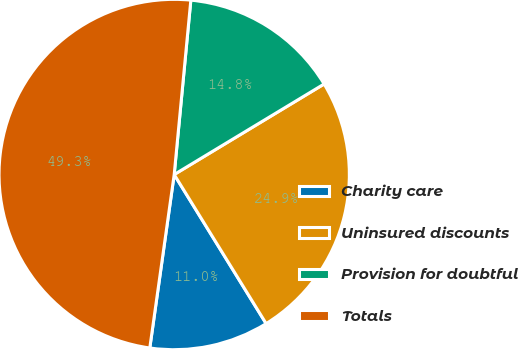Convert chart. <chart><loc_0><loc_0><loc_500><loc_500><pie_chart><fcel>Charity care<fcel>Uninsured discounts<fcel>Provision for doubtful<fcel>Totals<nl><fcel>11.02%<fcel>24.85%<fcel>14.84%<fcel>49.29%<nl></chart> 